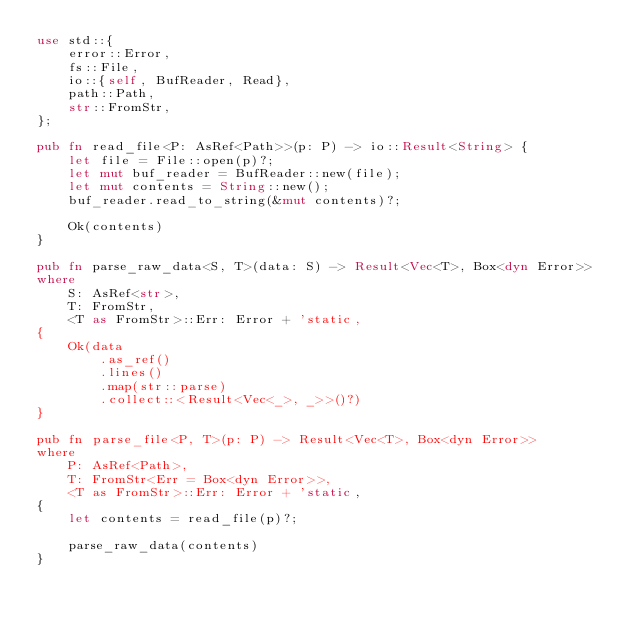<code> <loc_0><loc_0><loc_500><loc_500><_Rust_>use std::{
    error::Error,
    fs::File,
    io::{self, BufReader, Read},
    path::Path,
    str::FromStr,
};

pub fn read_file<P: AsRef<Path>>(p: P) -> io::Result<String> {
    let file = File::open(p)?;
    let mut buf_reader = BufReader::new(file);
    let mut contents = String::new();
    buf_reader.read_to_string(&mut contents)?;

    Ok(contents)
}

pub fn parse_raw_data<S, T>(data: S) -> Result<Vec<T>, Box<dyn Error>>
where
    S: AsRef<str>,
    T: FromStr,
    <T as FromStr>::Err: Error + 'static,
{
    Ok(data
        .as_ref()
        .lines()
        .map(str::parse)
        .collect::<Result<Vec<_>, _>>()?)
}

pub fn parse_file<P, T>(p: P) -> Result<Vec<T>, Box<dyn Error>>
where
    P: AsRef<Path>,
    T: FromStr<Err = Box<dyn Error>>,
    <T as FromStr>::Err: Error + 'static,
{
    let contents = read_file(p)?;

    parse_raw_data(contents)
}
</code> 